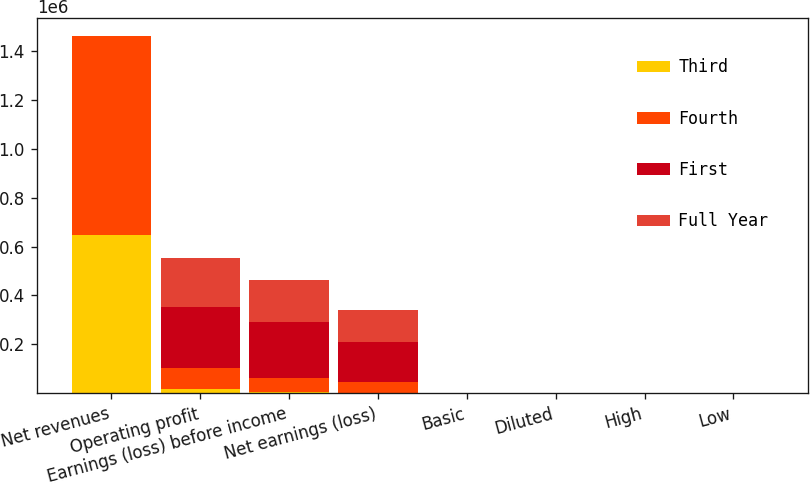Convert chart to OTSL. <chart><loc_0><loc_0><loc_500><loc_500><stacked_bar_chart><ecel><fcel>Net revenues<fcel>Operating profit<fcel>Earnings (loss) before income<fcel>Net earnings (loss)<fcel>Basic<fcel>Diluted<fcel>High<fcel>Low<nl><fcel>Third<fcel>648850<fcel>15726<fcel>4866<fcel>2579<fcel>0.02<fcel>0.02<fcel>37.7<fcel>31.51<nl><fcel>Fourth<fcel>811467<fcel>86282<fcel>59659<fcel>43427<fcel>0.33<fcel>0.33<fcel>37.55<fcel>32<nl><fcel>First<fcel>39.97<fcel>249622<fcel>224949<fcel>164852<fcel>1.26<fcel>1.24<fcel>39.98<fcel>32.29<nl><fcel>Full Year<fcel>39.97<fcel>200155<fcel>173660<fcel>130299<fcel>1<fcel>0.99<fcel>39.96<fcel>34.91<nl></chart> 